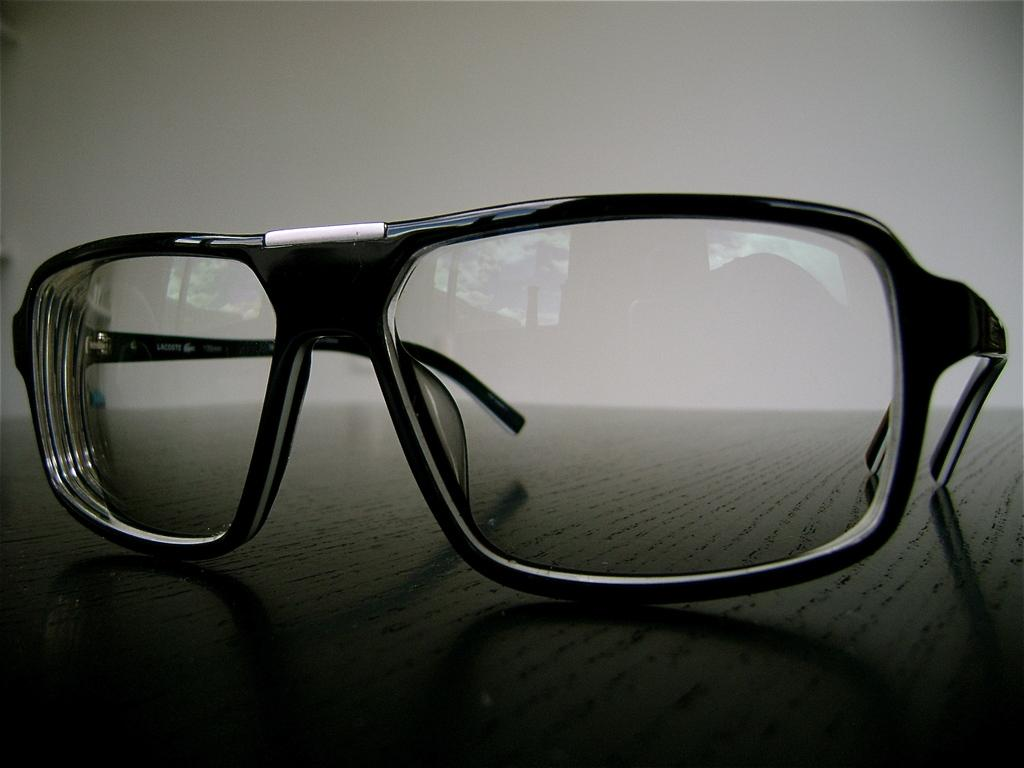What object is present on the surface in the image? There are spectacles on the surface in the image. What color is the background of the image? The background of the image is ash-colored. How many feet can be seen in the image? There are no feet visible in the image. What type of linen is draped over the spectacles in the image? There is no linen present in the image. 